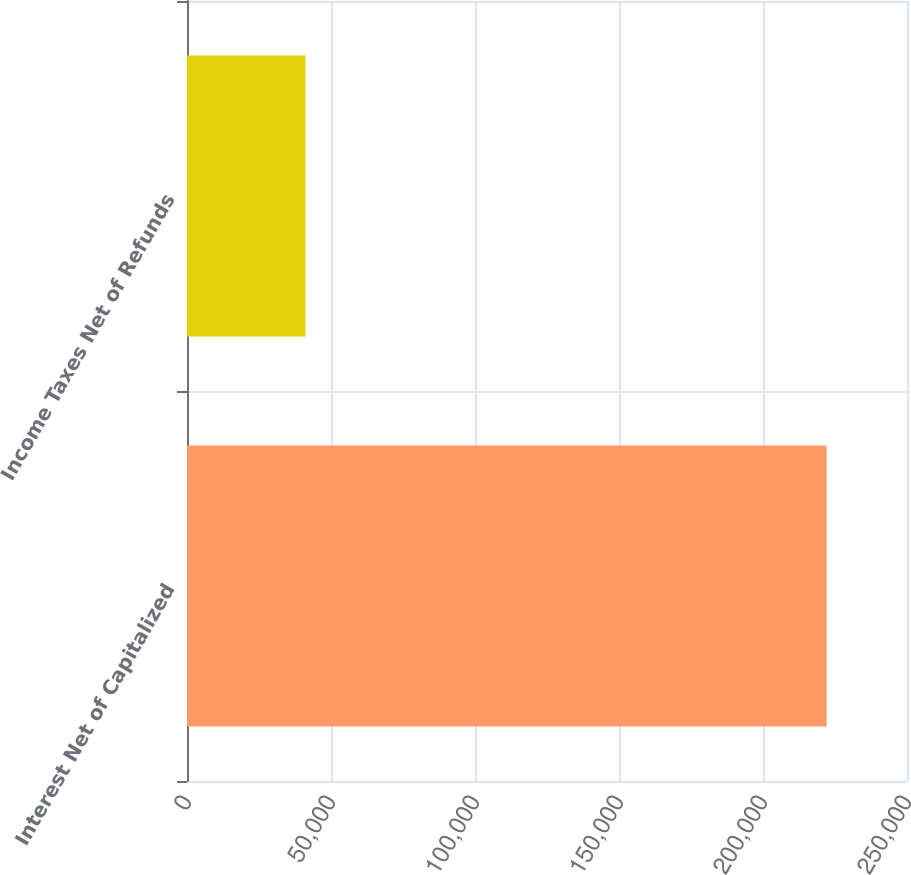Convert chart. <chart><loc_0><loc_0><loc_500><loc_500><bar_chart><fcel>Interest Net of Capitalized<fcel>Income Taxes Net of Refunds<nl><fcel>222088<fcel>41108<nl></chart> 